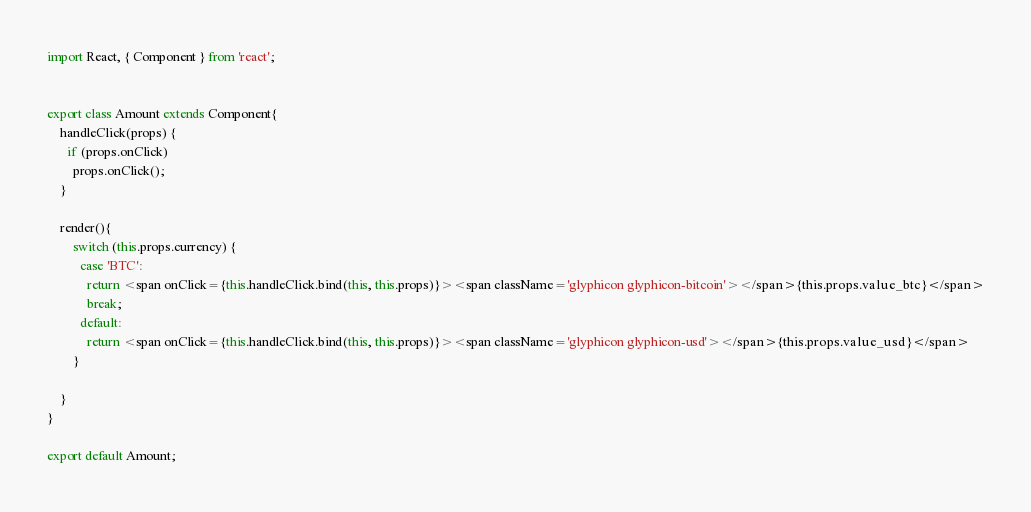<code> <loc_0><loc_0><loc_500><loc_500><_JavaScript_>import React, { Component } from 'react';


export class Amount extends Component{
    handleClick(props) {
      if (props.onClick)
        props.onClick();
    }

    render(){
        switch (this.props.currency) {
          case 'BTC':
            return <span onClick={this.handleClick.bind(this, this.props)}><span className='glyphicon glyphicon-bitcoin'></span>{this.props.value_btc}</span>
            break;
          default:
            return <span onClick={this.handleClick.bind(this, this.props)}><span className='glyphicon glyphicon-usd'></span>{this.props.value_usd}</span>
        }

    }
}

export default Amount;
</code> 